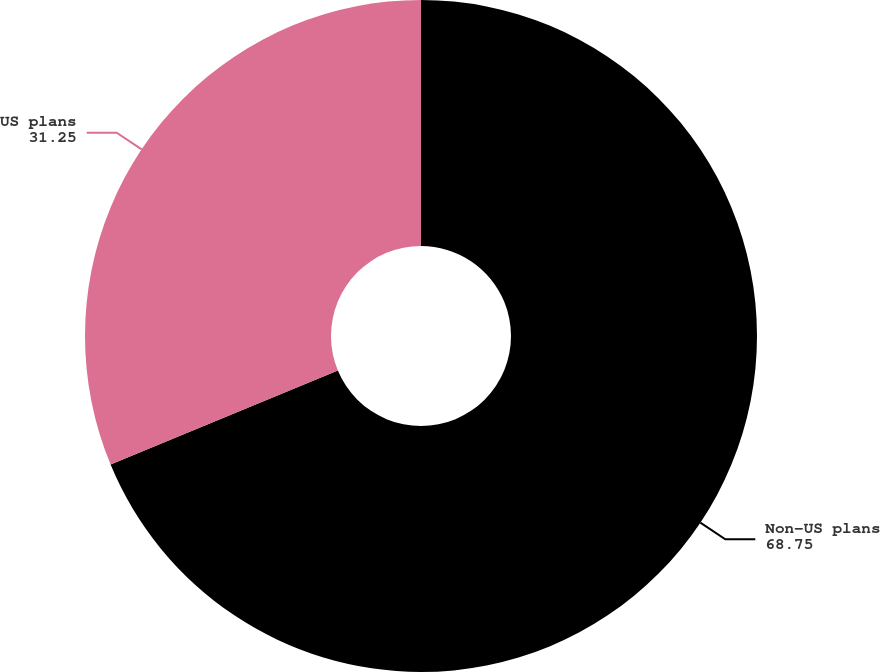<chart> <loc_0><loc_0><loc_500><loc_500><pie_chart><fcel>Non-US plans<fcel>US plans<nl><fcel>68.75%<fcel>31.25%<nl></chart> 